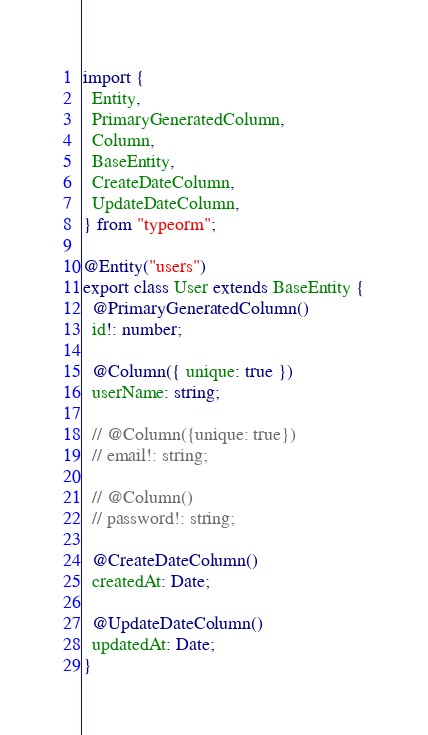Convert code to text. <code><loc_0><loc_0><loc_500><loc_500><_TypeScript_>import {
  Entity,
  PrimaryGeneratedColumn,
  Column,
  BaseEntity,
  CreateDateColumn,
  UpdateDateColumn,
} from "typeorm";

@Entity("users")
export class User extends BaseEntity {
  @PrimaryGeneratedColumn()
  id!: number;

  @Column({ unique: true })
  userName: string;

  // @Column({unique: true})
  // email!: string;

  // @Column()
  // password!: string;

  @CreateDateColumn()
  createdAt: Date;

  @UpdateDateColumn()
  updatedAt: Date;
}
</code> 